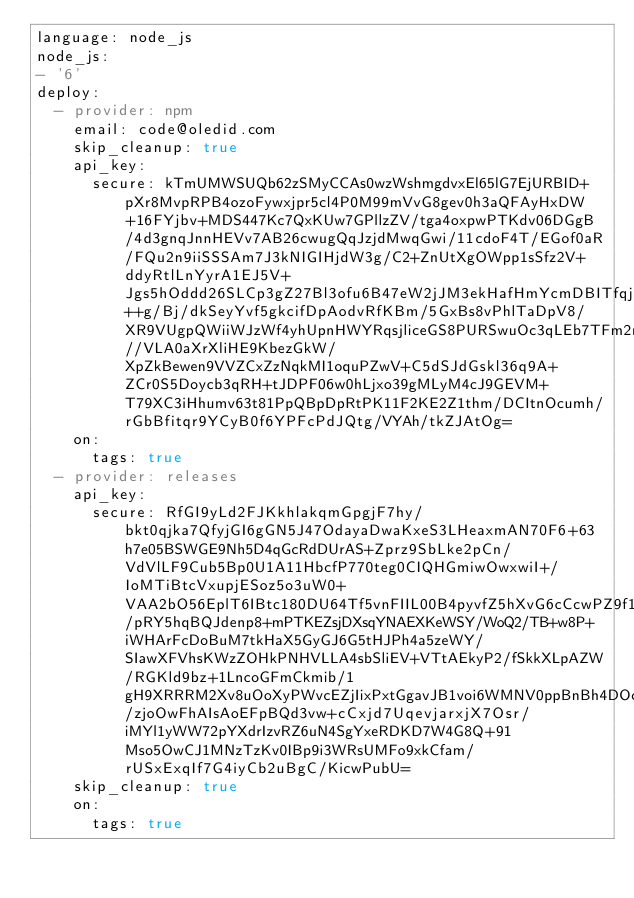<code> <loc_0><loc_0><loc_500><loc_500><_YAML_>language: node_js
node_js:
- '6'
deploy:
  - provider: npm
    email: code@oledid.com
    skip_cleanup: true
    api_key:
      secure: kTmUMWSUQb62zSMyCCAs0wzWshmgdvxEl65lG7EjURBID+pXr8MvpRPB4ozoFywxjpr5cl4P0M99mVvG8gev0h3aQFAyHxDW+16FYjbv+MDS447Kc7QxKUw7GPllzZV/tga4oxpwPTKdv06DGgB/4d3gnqJnnHEVv7AB26cwugQqJzjdMwqGwi/11cdoF4T/EGof0aR/FQu2n9iiSSSAm7J3kNIGIHjdW3g/C2+ZnUtXgOWpp1sSfz2V+ddyRtlLnYyrA1EJ5V+Jgs5hOddd26SLCp3gZ27Bl3ofu6B47eW2jJM3ekHafHmYcmDBITfqj3MIdaLxf9Ent1BaqFIIlrnK4txfSH0KsBN++g/Bj/dkSeyYvf5gkcifDpAodvRfKBm/5GxBs8vPhlTaDpV8/XR9VUgpQWiiWJzWf4yhUpnHWYRqsjliceGS8PURSwuOc3qLEb7TFm2r5uvpD3b2krB3kZ//VLA0aXrXliHE9KbezGkW/XpZkBewen9VVZCxZzNqkMI1oquPZwV+C5dSJdGskl36q9A+ZCr0S5Doycb3qRH+tJDPF06w0hLjxo39gMLyM4cJ9GEVM+T79XC3iHhumv63t81PpQBpDpRtPK11F2KE2Z1thm/DCItnOcumh/rGbBfitqr9YCyB0f6YPFcPdJQtg/VYAh/tkZJAtOg=
    on:
      tags: true
  - provider: releases
    api_key:
      secure: RfGI9yLd2FJKkhlakqmGpgjF7hy/bkt0qjka7QfyjGI6gGN5J47OdayaDwaKxeS3LHeaxmAN70F6+63h7e05BSWGE9Nh5D4qGcRdDUrAS+Zprz9SbLke2pCn/VdVlLF9Cub5Bp0U1A11HbcfP770teg0CIQHGmiwOwxwiI+/IoMTiBtcVxupjESoz5o3uW0+VAA2bO56EplT6IBtc180DU64Tf5vnFIIL00B4pyvfZ5hXvG6cCcwPZ9f1OI0WV1tcvPOPgFVOo8OXBy0OnVex886K5iR2B6OsiJSkBPnDwi8qo6/pRY5hqBQJdenp8+mPTKEZsjDXsqYNAEXKeWSY/WoQ2/TB+w8P+iWHArFcDoBuM7tkHaX5GyGJ6G5tHJPh4a5zeWY/SIawXFVhsKWzZOHkPNHVLLA4sbSliEV+VTtAEkyP2/fSkkXLpAZW/RGKld9bz+1LncoGFmCkmib/1gH9XRRRM2Xv8uOoXyPWvcEZjIixPxtGgavJB1voi6WMNV0ppBnBh4DOcGKJ/zjoOwFhAIsAoEFpBQd3vw+cCxjd7UqevjarxjX7Osr/iMYl1yWW72pYXdrIzvRZ6uN4SgYxeRDKD7W4G8Q+91Mso5OwCJ1MNzTzKv0IBp9i3WRsUMFo9xkCfam/rUSxExqIf7G4iyCb2uBgC/KicwPubU=
    skip_cleanup: true
    on:
      tags: true
</code> 